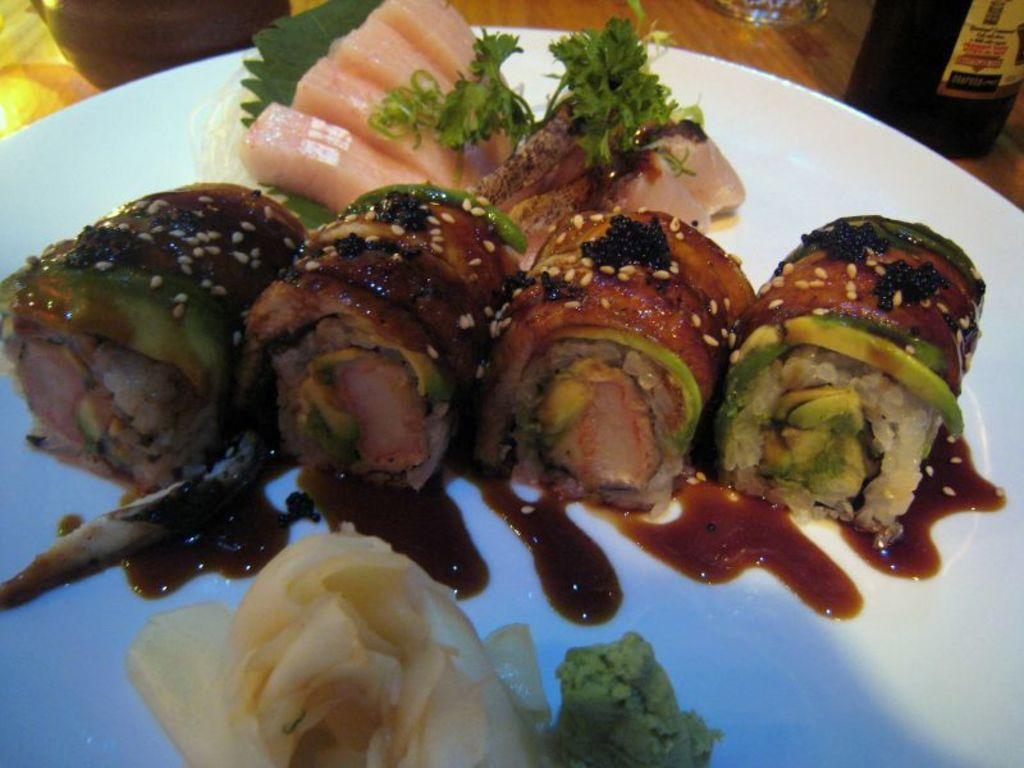What is on the serving plate in the image? The serving plate contains food. Where is the serving plate located? The serving plate is placed on a table. What type of sack can be seen in the image? There is no sack present in the image. What root is growing from the food on the serving plate? There are no roots growing from the food on the serving plate in the image. 